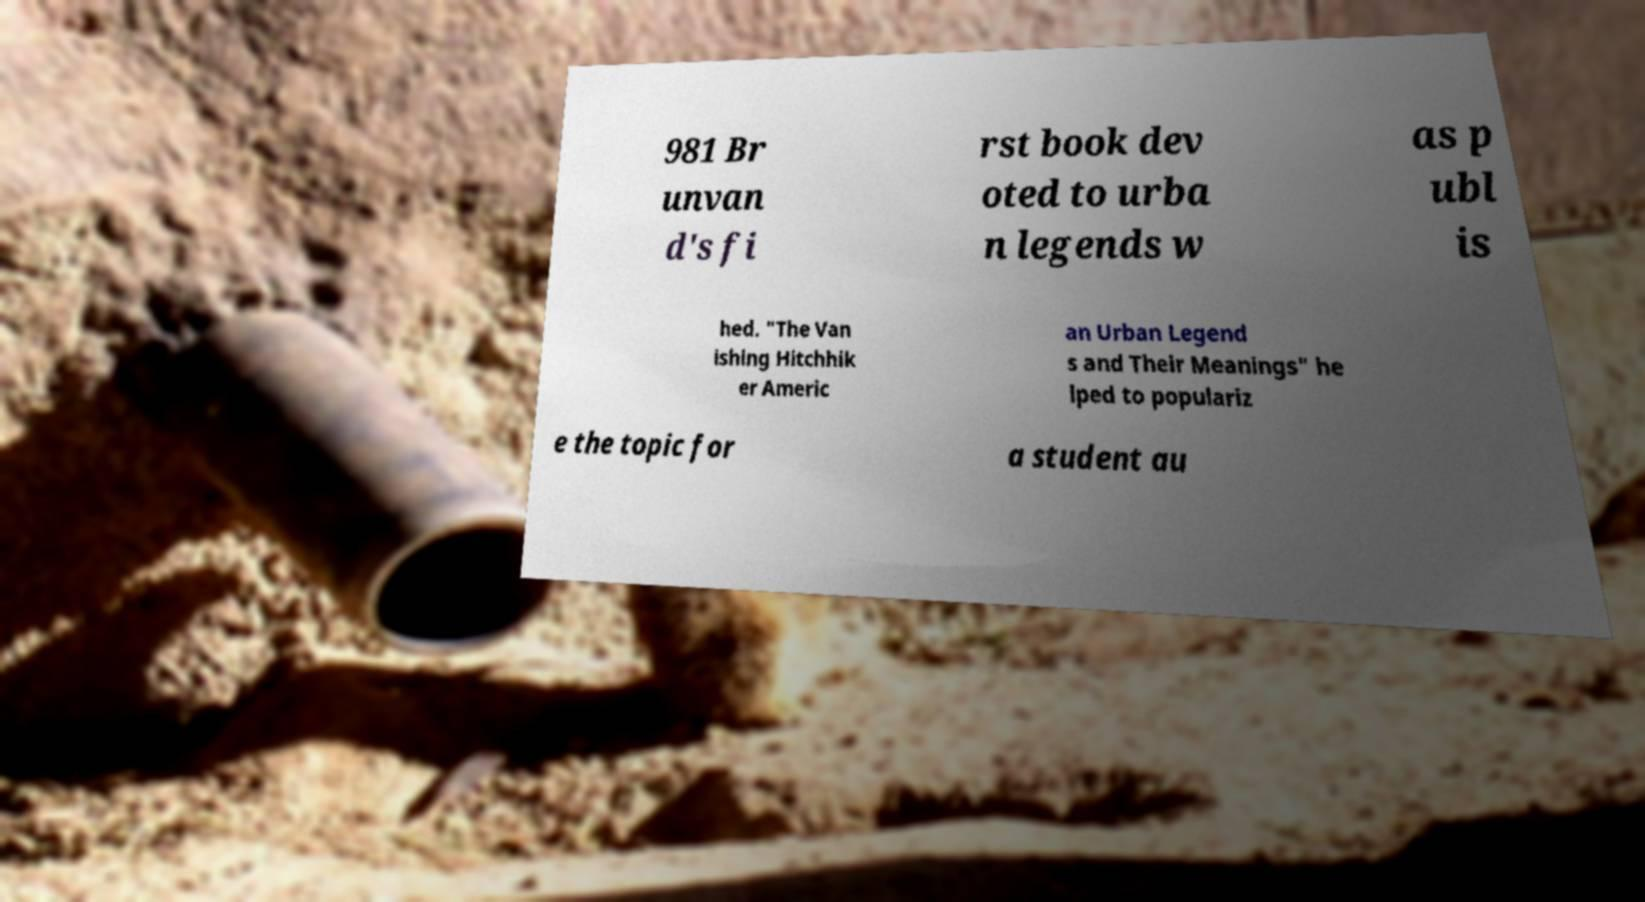Can you accurately transcribe the text from the provided image for me? 981 Br unvan d's fi rst book dev oted to urba n legends w as p ubl is hed. "The Van ishing Hitchhik er Americ an Urban Legend s and Their Meanings" he lped to populariz e the topic for a student au 